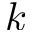<formula> <loc_0><loc_0><loc_500><loc_500>k</formula> 